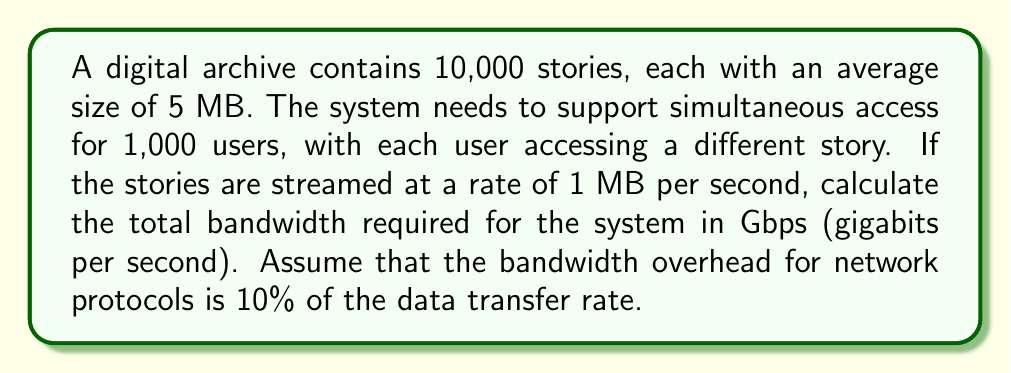Give your solution to this math problem. To solve this problem, we'll follow these steps:

1. Calculate the data transfer rate for one user:
   $$ \text{Rate per user} = 1 \text{ MB/s} = 8 \text{ Mb/s} $$

2. Calculate the total data transfer rate for all users:
   $$ \text{Total rate} = 1,000 \text{ users} \times 8 \text{ Mb/s} = 8,000 \text{ Mb/s} $$

3. Account for the 10% bandwidth overhead:
   $$ \text{Overhead} = 8,000 \text{ Mb/s} \times 0.10 = 800 \text{ Mb/s} $$

4. Calculate the total bandwidth required:
   $$ \text{Total bandwidth} = 8,000 \text{ Mb/s} + 800 \text{ Mb/s} = 8,800 \text{ Mb/s} $$

5. Convert the result to Gbps:
   $$ \text{Total bandwidth in Gbps} = \frac{8,800 \text{ Mb/s}}{1,000 \text{ Mb/Gb}} = 8.8 \text{ Gbps} $$
Answer: The total bandwidth required for simultaneous access to the archived stories is 8.8 Gbps. 